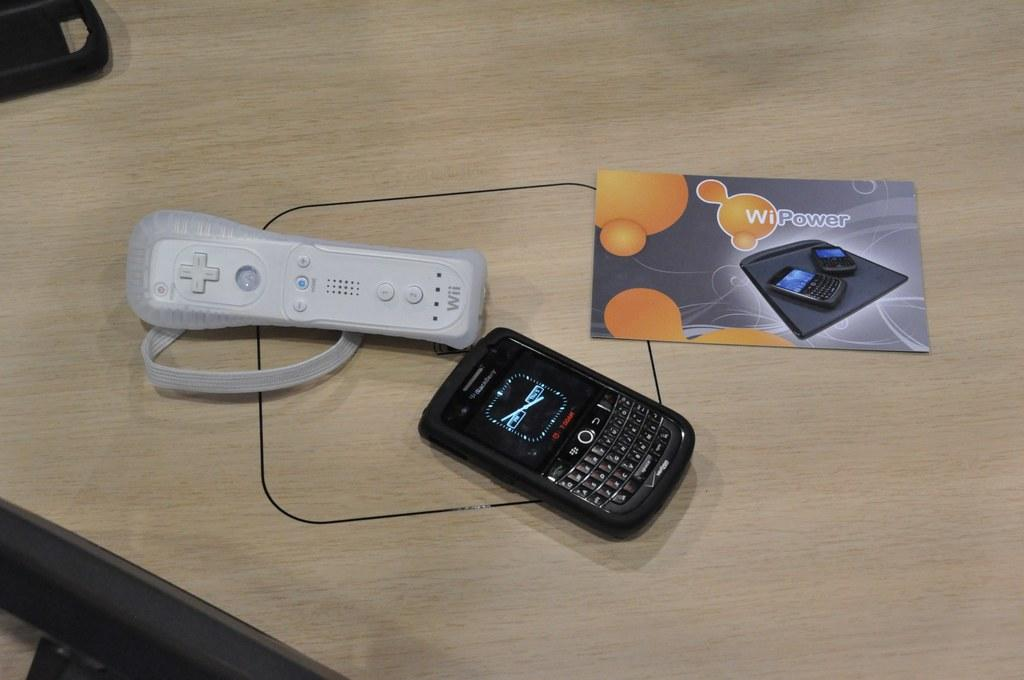<image>
Render a clear and concise summary of the photo. A Wii remote sits next to a black Blackerry. 